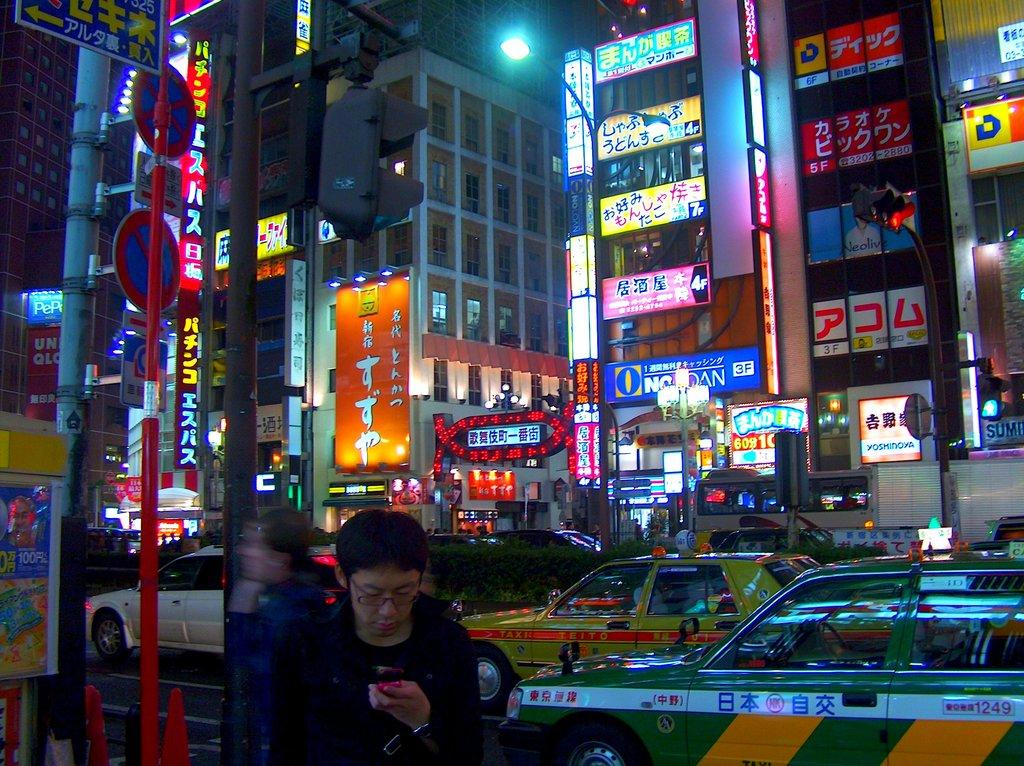Provide a one-sentence caption for the provided image. Taxis are driving past buildlings adorned with neon signs in Japan. 